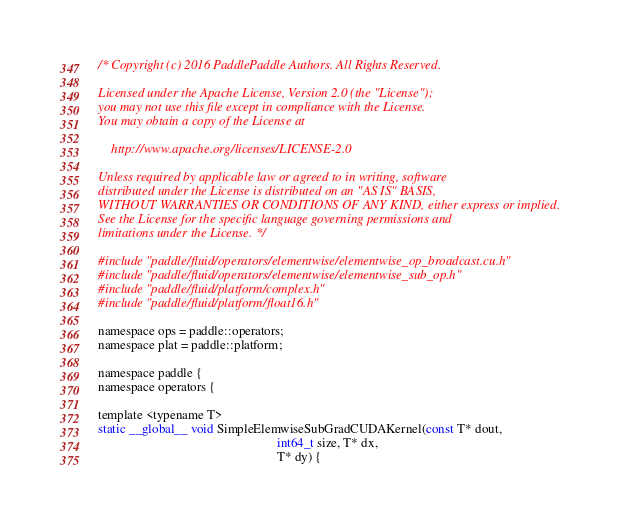Convert code to text. <code><loc_0><loc_0><loc_500><loc_500><_Cuda_>/* Copyright (c) 2016 PaddlePaddle Authors. All Rights Reserved.

Licensed under the Apache License, Version 2.0 (the "License");
you may not use this file except in compliance with the License.
You may obtain a copy of the License at

    http://www.apache.org/licenses/LICENSE-2.0

Unless required by applicable law or agreed to in writing, software
distributed under the License is distributed on an "AS IS" BASIS,
WITHOUT WARRANTIES OR CONDITIONS OF ANY KIND, either express or implied.
See the License for the specific language governing permissions and
limitations under the License. */

#include "paddle/fluid/operators/elementwise/elementwise_op_broadcast.cu.h"
#include "paddle/fluid/operators/elementwise/elementwise_sub_op.h"
#include "paddle/fluid/platform/complex.h"
#include "paddle/fluid/platform/float16.h"

namespace ops = paddle::operators;
namespace plat = paddle::platform;

namespace paddle {
namespace operators {

template <typename T>
static __global__ void SimpleElemwiseSubGradCUDAKernel(const T* dout,
                                                       int64_t size, T* dx,
                                                       T* dy) {</code> 